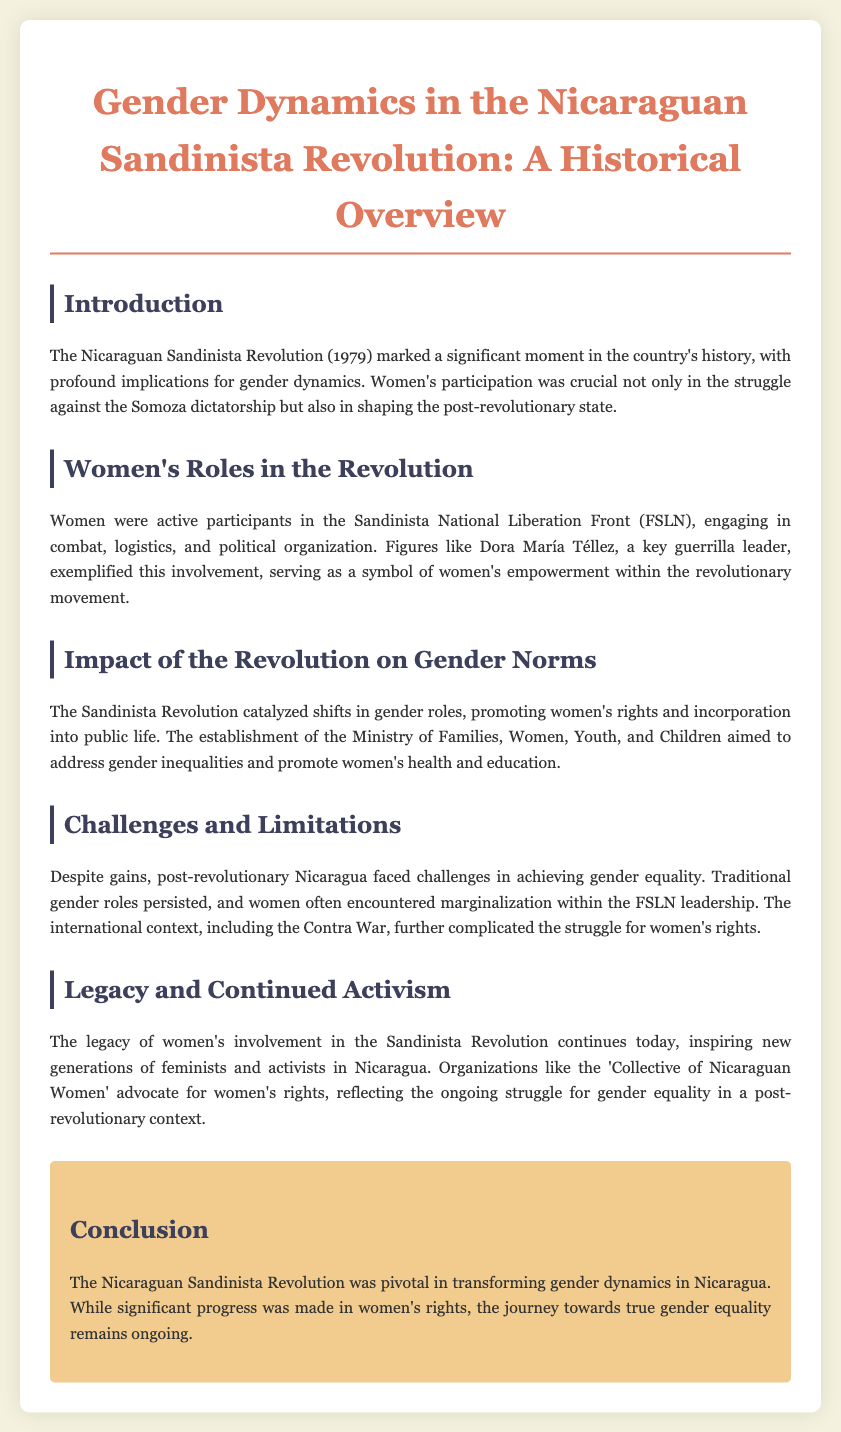What year did the Nicaraguan Sandinista Revolution occur? The year of the Nicaraguan Sandinista Revolution is mentioned in the introduction section.
Answer: 1979 Who was a key guerrilla leader mentioned in the document? The document highlights a notable female figure involved in the revolution.
Answer: Dora María Téllez What organization did women participate in during the revolution? The document refers to a specific liberation front that women were part of.
Answer: FSLN What was established to address gender inequalities post-revolution? The introduction discusses a governmental body aimed at promoting women's rights and public life.
Answer: Ministry of Families, Women, Youth, and Children What ongoing challenge is mentioned regarding gender equality post-revolution? The document discusses a particular challenge that persists despite progress, particularly related to gender roles.
Answer: Traditional gender roles What kind of activism is inspired by the legacy of the Sandinista Revolution? The document alludes to a particular movement that continues to advocate for women's rights today.
Answer: Feminism What war complicated the struggle for women's rights in Nicaragua? A specific conflict is noted in the document that affected the women's rights movement.
Answer: Contra War What impact did the Sandinista Revolution have on women's rights? The introduction outlines the changes that took place regarding women's roles and rights.
Answer: Catalyzed shifts 